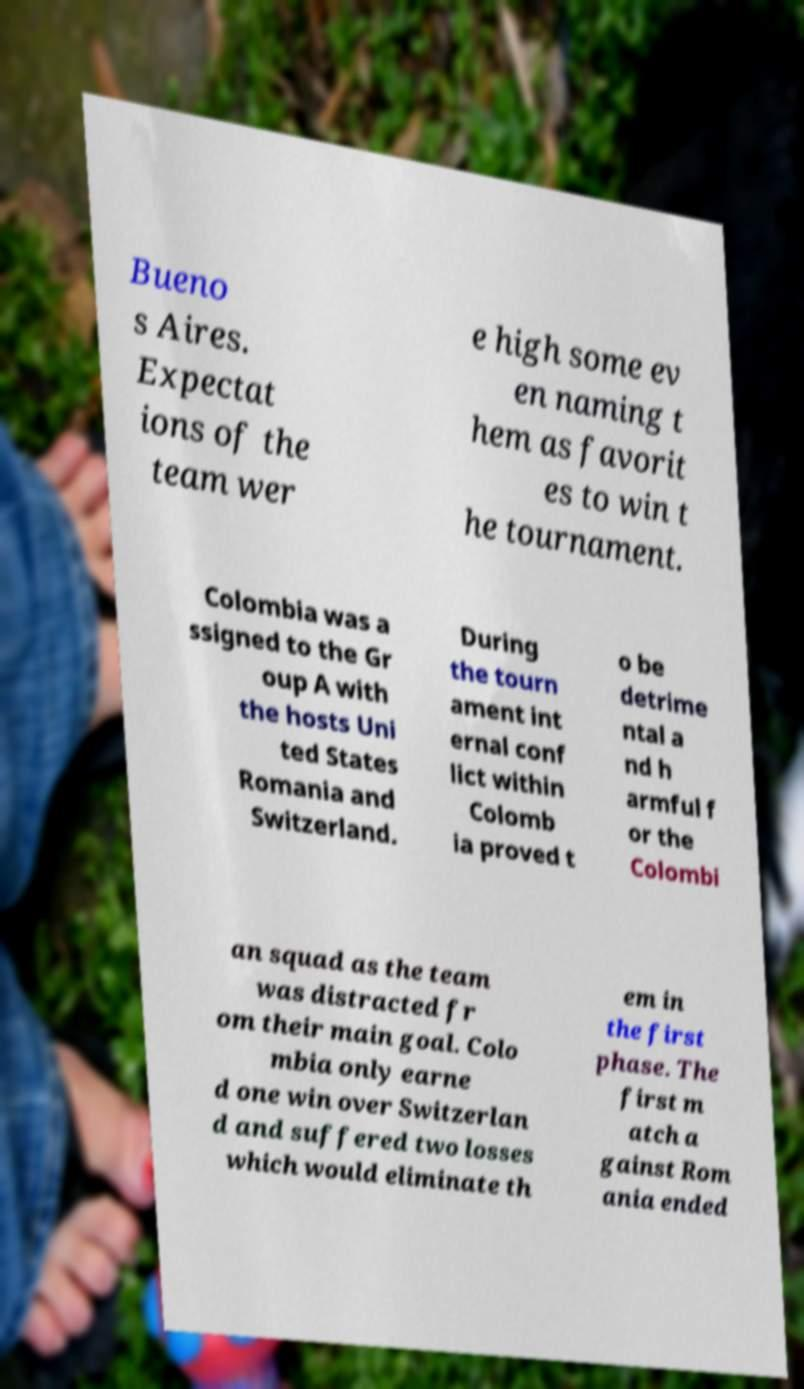For documentation purposes, I need the text within this image transcribed. Could you provide that? Bueno s Aires. Expectat ions of the team wer e high some ev en naming t hem as favorit es to win t he tournament. Colombia was a ssigned to the Gr oup A with the hosts Uni ted States Romania and Switzerland. During the tourn ament int ernal conf lict within Colomb ia proved t o be detrime ntal a nd h armful f or the Colombi an squad as the team was distracted fr om their main goal. Colo mbia only earne d one win over Switzerlan d and suffered two losses which would eliminate th em in the first phase. The first m atch a gainst Rom ania ended 